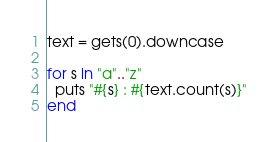<code> <loc_0><loc_0><loc_500><loc_500><_Ruby_>text = gets(0).downcase

for s in "a".."z"
  puts "#{s} : #{text.count(s)}"
end

</code> 